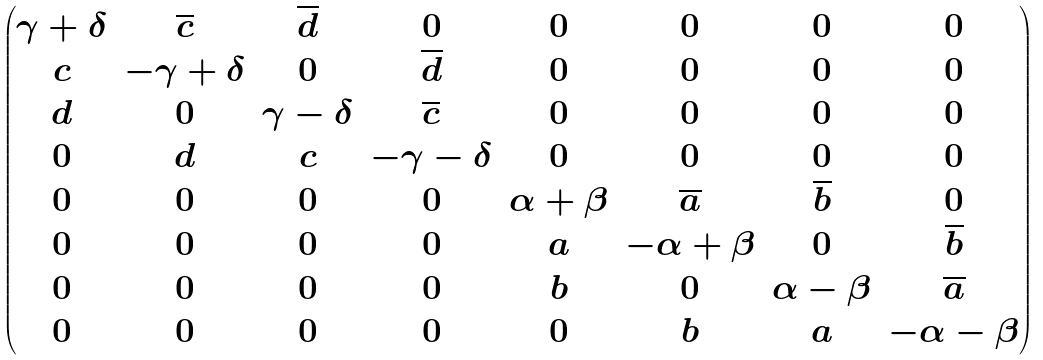<formula> <loc_0><loc_0><loc_500><loc_500>\begin{pmatrix} \gamma + \delta & \overline { c } & \overline { d } & 0 & 0 & 0 & 0 & 0 \\ { c } & - \gamma + \delta & 0 & \overline { d } & 0 & 0 & 0 & 0 \\ { d } & 0 & \gamma - \delta & \overline { c } & 0 & 0 & 0 & 0 \\ 0 & { d } & { c } & - \gamma - \delta & 0 & 0 & 0 & 0 \\ 0 & 0 & 0 & 0 & \alpha + \beta & \overline { a } & \overline { b } & 0 \\ 0 & 0 & 0 & 0 & { a } & - \alpha + \beta & 0 & \overline { b } \\ 0 & 0 & 0 & 0 & b & 0 & \alpha - \beta & \overline { a } \\ 0 & 0 & 0 & 0 & 0 & b & { a } & - \alpha - \beta \end{pmatrix}</formula> 